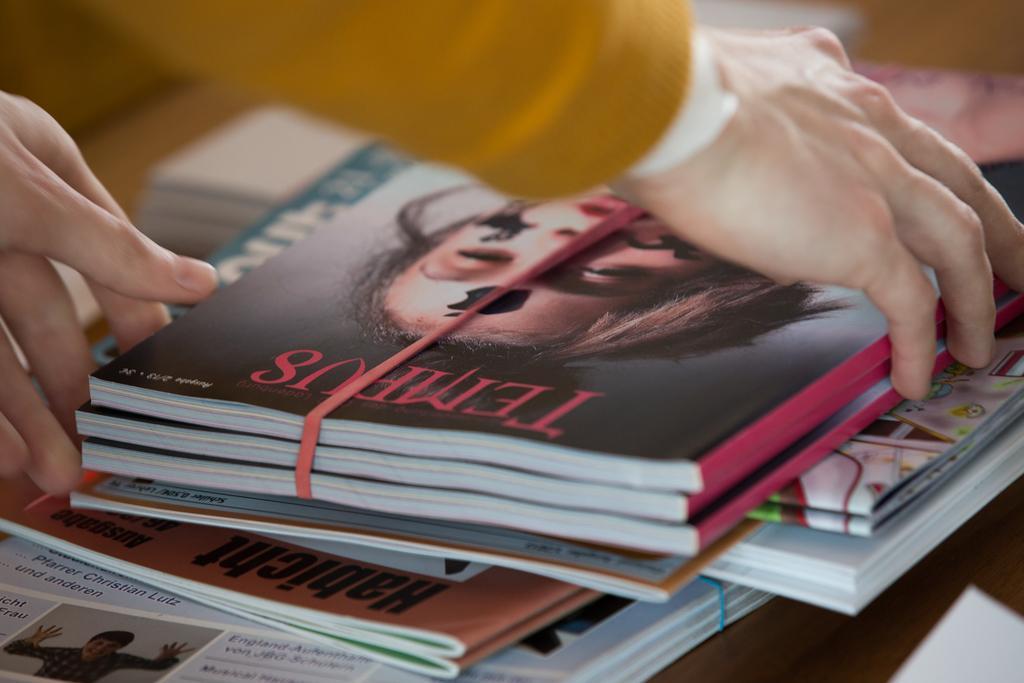Can you describe this image briefly? In this image we can see the hands of a person who is holding the books. At the bottom there are so many books kept one above the other. 